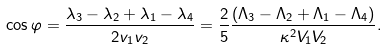<formula> <loc_0><loc_0><loc_500><loc_500>\cos \varphi = \frac { \lambda _ { 3 } - \lambda _ { 2 } + \lambda _ { 1 } - \lambda _ { 4 } } { 2 v _ { 1 } v _ { 2 } } = \frac { 2 } { 5 } \frac { ( \Lambda _ { 3 } - \Lambda _ { 2 } + \Lambda _ { 1 } - \Lambda _ { 4 } ) } { \kappa ^ { 2 } V _ { 1 } V _ { 2 } } .</formula> 